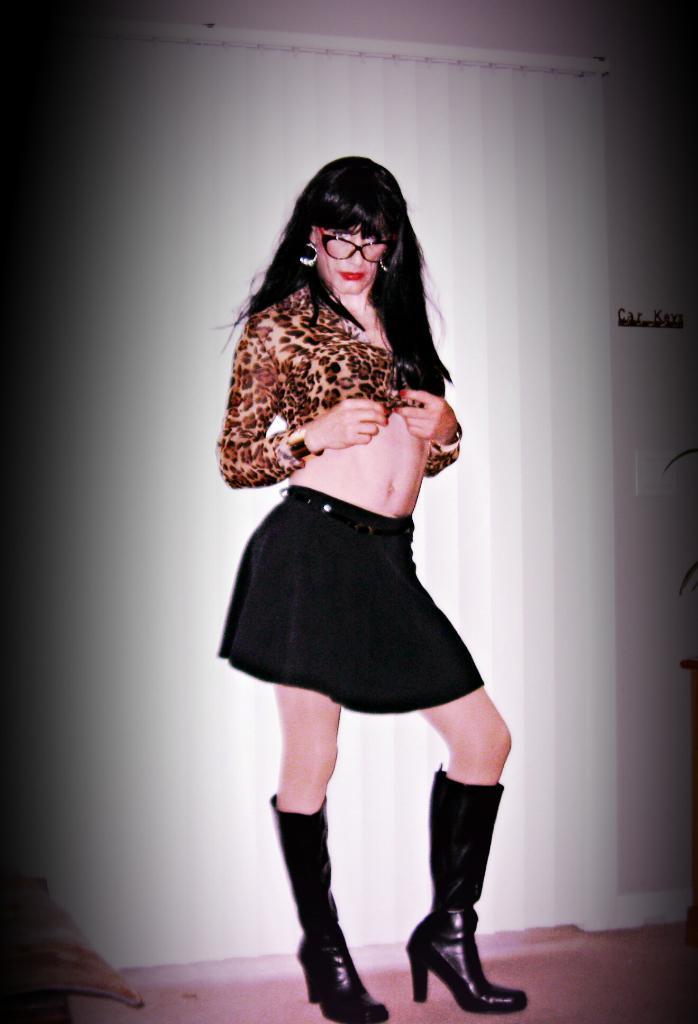In one or two sentences, can you explain what this image depicts? In the middle of the picture, we see a woman in black dress is stunning. She is wearing the spectacles and she is also wearing the shoes. In the background, we see a white curtain and a white wall. In the left bottom of the picture, we see a table. This picture is clicked inside the room. 